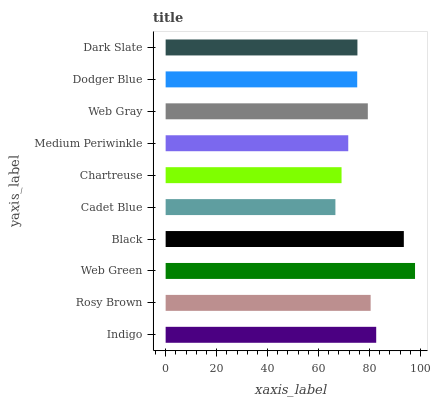Is Cadet Blue the minimum?
Answer yes or no. Yes. Is Web Green the maximum?
Answer yes or no. Yes. Is Rosy Brown the minimum?
Answer yes or no. No. Is Rosy Brown the maximum?
Answer yes or no. No. Is Indigo greater than Rosy Brown?
Answer yes or no. Yes. Is Rosy Brown less than Indigo?
Answer yes or no. Yes. Is Rosy Brown greater than Indigo?
Answer yes or no. No. Is Indigo less than Rosy Brown?
Answer yes or no. No. Is Web Gray the high median?
Answer yes or no. Yes. Is Dark Slate the low median?
Answer yes or no. Yes. Is Dark Slate the high median?
Answer yes or no. No. Is Web Green the low median?
Answer yes or no. No. 